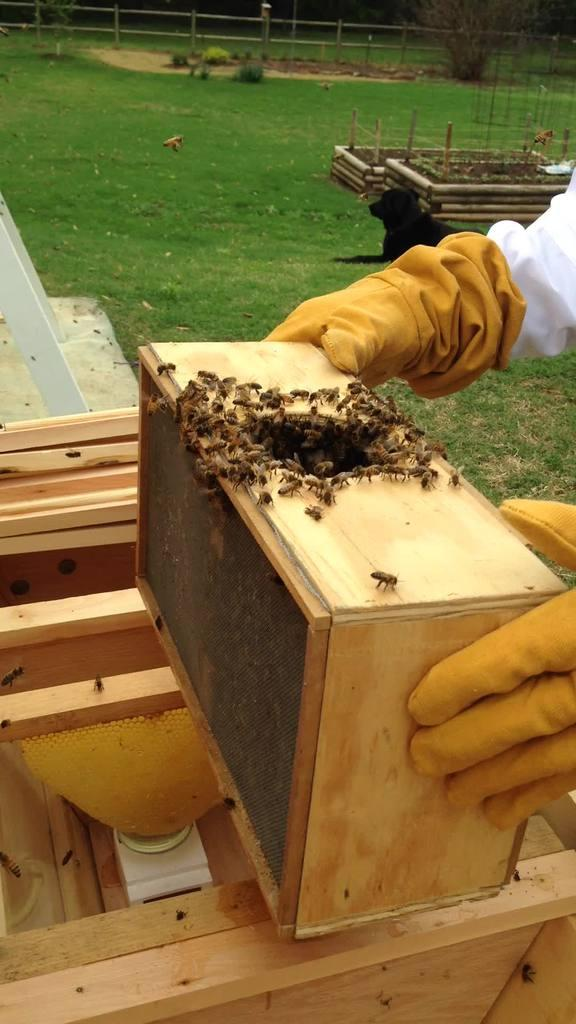What is the person in the image wearing on their hands? The person in the image is wearing gloves on their hands. What type of insects can be seen in the image? Honey bees can be seen in the image. What structures are associated with the honey bees in the image? There are bee hive boxes in the image. What type of support structures are present in the image? There are poles in the image. What type of animal is sitting on the grass in the image? There is a dog sitting on the grass in the image. What type of vegetation is present in the image? There are plants and a tree in the image. Where is the church located in the image? There is no church present in the image. What type of crate is being used to store the honey bees in the image? There are no crates present in the image; honey bees are associated with bee hive boxes. 